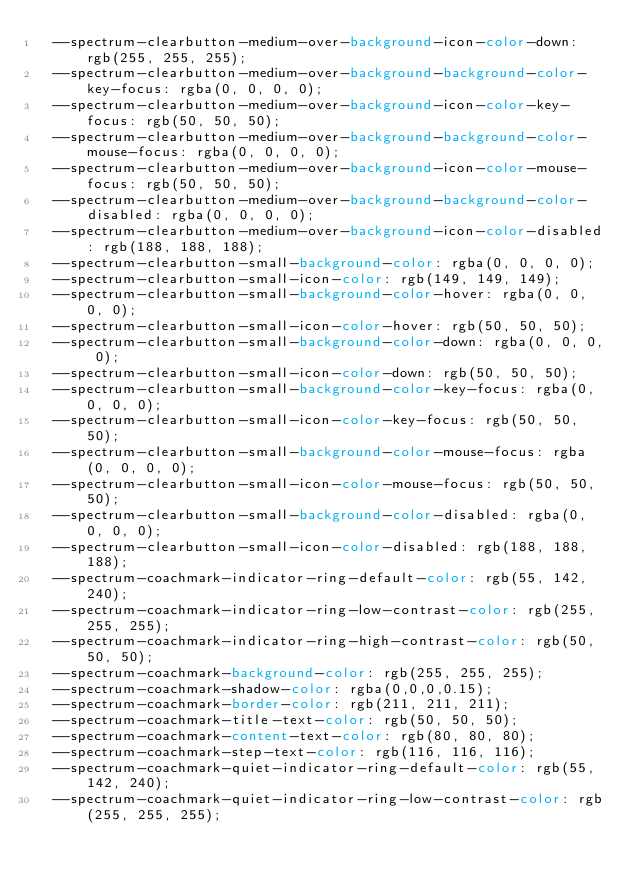Convert code to text. <code><loc_0><loc_0><loc_500><loc_500><_CSS_>  --spectrum-clearbutton-medium-over-background-icon-color-down: rgb(255, 255, 255);
  --spectrum-clearbutton-medium-over-background-background-color-key-focus: rgba(0, 0, 0, 0);
  --spectrum-clearbutton-medium-over-background-icon-color-key-focus: rgb(50, 50, 50);
  --spectrum-clearbutton-medium-over-background-background-color-mouse-focus: rgba(0, 0, 0, 0);
  --spectrum-clearbutton-medium-over-background-icon-color-mouse-focus: rgb(50, 50, 50);
  --spectrum-clearbutton-medium-over-background-background-color-disabled: rgba(0, 0, 0, 0);
  --spectrum-clearbutton-medium-over-background-icon-color-disabled: rgb(188, 188, 188);
  --spectrum-clearbutton-small-background-color: rgba(0, 0, 0, 0);
  --spectrum-clearbutton-small-icon-color: rgb(149, 149, 149);
  --spectrum-clearbutton-small-background-color-hover: rgba(0, 0, 0, 0);
  --spectrum-clearbutton-small-icon-color-hover: rgb(50, 50, 50);
  --spectrum-clearbutton-small-background-color-down: rgba(0, 0, 0, 0);
  --spectrum-clearbutton-small-icon-color-down: rgb(50, 50, 50);
  --spectrum-clearbutton-small-background-color-key-focus: rgba(0, 0, 0, 0);
  --spectrum-clearbutton-small-icon-color-key-focus: rgb(50, 50, 50);
  --spectrum-clearbutton-small-background-color-mouse-focus: rgba(0, 0, 0, 0);
  --spectrum-clearbutton-small-icon-color-mouse-focus: rgb(50, 50, 50);
  --spectrum-clearbutton-small-background-color-disabled: rgba(0, 0, 0, 0);
  --spectrum-clearbutton-small-icon-color-disabled: rgb(188, 188, 188);
  --spectrum-coachmark-indicator-ring-default-color: rgb(55, 142, 240);
  --spectrum-coachmark-indicator-ring-low-contrast-color: rgb(255, 255, 255);
  --spectrum-coachmark-indicator-ring-high-contrast-color: rgb(50, 50, 50);
  --spectrum-coachmark-background-color: rgb(255, 255, 255);
  --spectrum-coachmark-shadow-color: rgba(0,0,0,0.15);
  --spectrum-coachmark-border-color: rgb(211, 211, 211);
  --spectrum-coachmark-title-text-color: rgb(50, 50, 50);
  --spectrum-coachmark-content-text-color: rgb(80, 80, 80);
  --spectrum-coachmark-step-text-color: rgb(116, 116, 116);
  --spectrum-coachmark-quiet-indicator-ring-default-color: rgb(55, 142, 240);
  --spectrum-coachmark-quiet-indicator-ring-low-contrast-color: rgb(255, 255, 255);</code> 